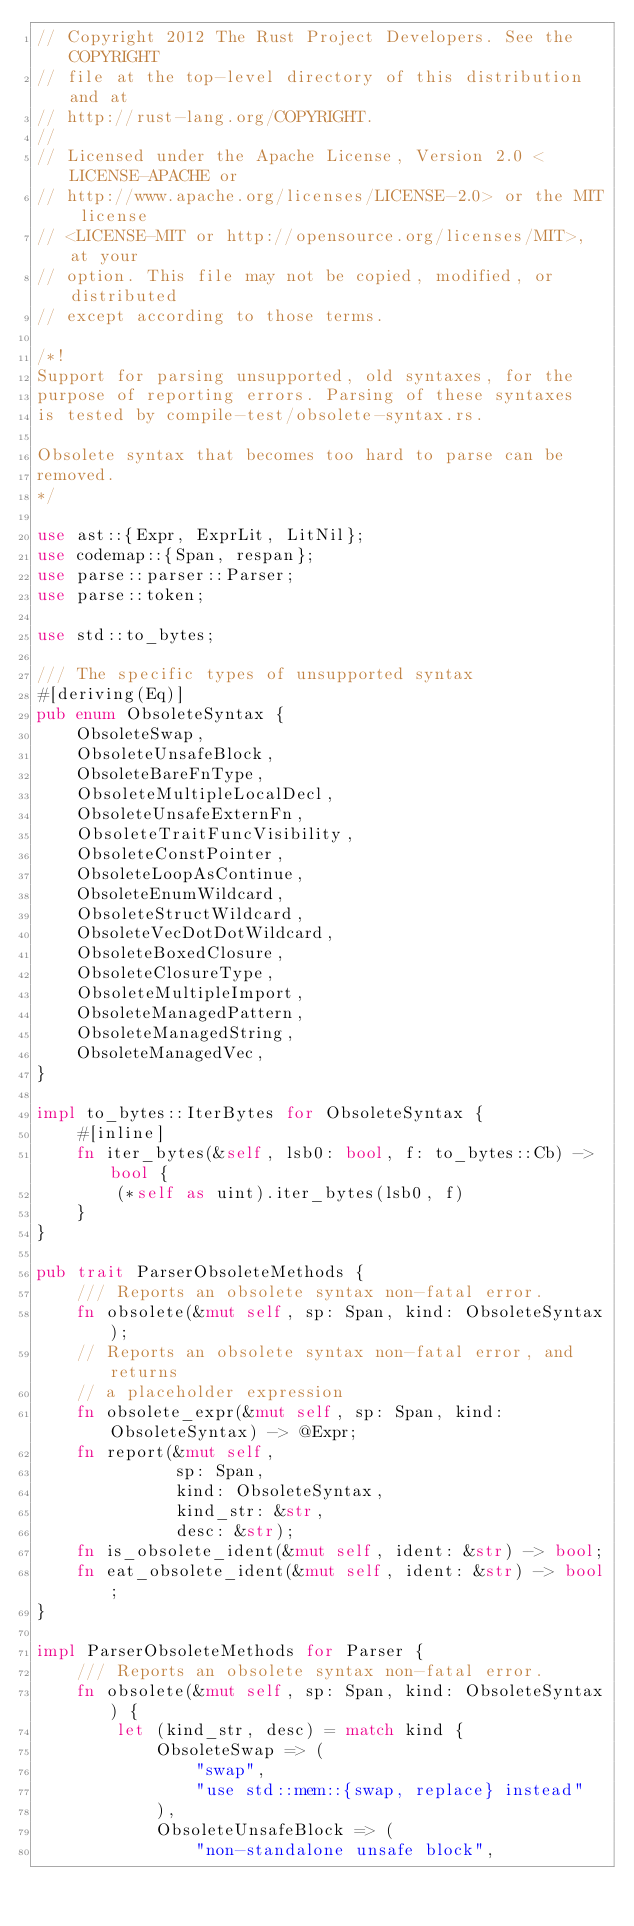Convert code to text. <code><loc_0><loc_0><loc_500><loc_500><_Rust_>// Copyright 2012 The Rust Project Developers. See the COPYRIGHT
// file at the top-level directory of this distribution and at
// http://rust-lang.org/COPYRIGHT.
//
// Licensed under the Apache License, Version 2.0 <LICENSE-APACHE or
// http://www.apache.org/licenses/LICENSE-2.0> or the MIT license
// <LICENSE-MIT or http://opensource.org/licenses/MIT>, at your
// option. This file may not be copied, modified, or distributed
// except according to those terms.

/*!
Support for parsing unsupported, old syntaxes, for the
purpose of reporting errors. Parsing of these syntaxes
is tested by compile-test/obsolete-syntax.rs.

Obsolete syntax that becomes too hard to parse can be
removed.
*/

use ast::{Expr, ExprLit, LitNil};
use codemap::{Span, respan};
use parse::parser::Parser;
use parse::token;

use std::to_bytes;

/// The specific types of unsupported syntax
#[deriving(Eq)]
pub enum ObsoleteSyntax {
    ObsoleteSwap,
    ObsoleteUnsafeBlock,
    ObsoleteBareFnType,
    ObsoleteMultipleLocalDecl,
    ObsoleteUnsafeExternFn,
    ObsoleteTraitFuncVisibility,
    ObsoleteConstPointer,
    ObsoleteLoopAsContinue,
    ObsoleteEnumWildcard,
    ObsoleteStructWildcard,
    ObsoleteVecDotDotWildcard,
    ObsoleteBoxedClosure,
    ObsoleteClosureType,
    ObsoleteMultipleImport,
    ObsoleteManagedPattern,
    ObsoleteManagedString,
    ObsoleteManagedVec,
}

impl to_bytes::IterBytes for ObsoleteSyntax {
    #[inline]
    fn iter_bytes(&self, lsb0: bool, f: to_bytes::Cb) -> bool {
        (*self as uint).iter_bytes(lsb0, f)
    }
}

pub trait ParserObsoleteMethods {
    /// Reports an obsolete syntax non-fatal error.
    fn obsolete(&mut self, sp: Span, kind: ObsoleteSyntax);
    // Reports an obsolete syntax non-fatal error, and returns
    // a placeholder expression
    fn obsolete_expr(&mut self, sp: Span, kind: ObsoleteSyntax) -> @Expr;
    fn report(&mut self,
              sp: Span,
              kind: ObsoleteSyntax,
              kind_str: &str,
              desc: &str);
    fn is_obsolete_ident(&mut self, ident: &str) -> bool;
    fn eat_obsolete_ident(&mut self, ident: &str) -> bool;
}

impl ParserObsoleteMethods for Parser {
    /// Reports an obsolete syntax non-fatal error.
    fn obsolete(&mut self, sp: Span, kind: ObsoleteSyntax) {
        let (kind_str, desc) = match kind {
            ObsoleteSwap => (
                "swap",
                "use std::mem::{swap, replace} instead"
            ),
            ObsoleteUnsafeBlock => (
                "non-standalone unsafe block",</code> 